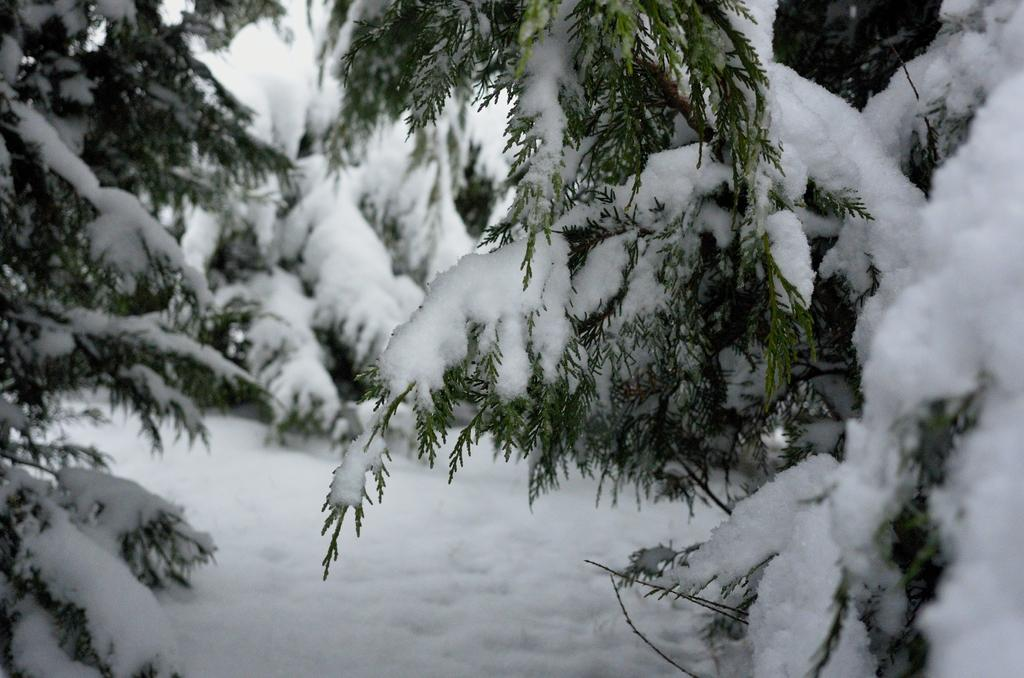What can be seen in the image in the image that is related to trees? There are tree branches in the image. What is the condition of the tree branches? The tree branches are covered in snow. What is the ground like in the image? There is snow on the ground in the image. How many pears are hanging from the tree branches in the image? There are no pears visible in the image; the tree branches are covered in snow. What type of amusement park can be seen in the background of the image? There is no amusement park present in the image; it only features tree branches covered in snow and snow on the ground. 